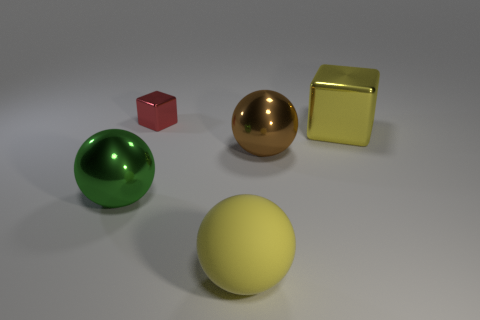What is the material of the big thing that is both left of the brown metal object and on the right side of the green metallic object?
Your answer should be compact. Rubber. How many other objects are the same color as the big matte ball?
Provide a succinct answer. 1. What material is the big brown object?
Your answer should be compact. Metal. Is there a large metallic block?
Provide a succinct answer. Yes. Are there the same number of big green things that are to the left of the green ball and cyan shiny balls?
Make the answer very short. Yes. Are there any other things that are the same material as the large yellow ball?
Make the answer very short. No. How many large objects are either green shiny objects or shiny spheres?
Provide a succinct answer. 2. What is the shape of the metal thing that is the same color as the large rubber ball?
Make the answer very short. Cube. Do the big ball that is to the left of the tiny red thing and the yellow ball have the same material?
Offer a terse response. No. What material is the big sphere behind the green metal ball that is on the left side of the red metallic thing?
Your response must be concise. Metal. 